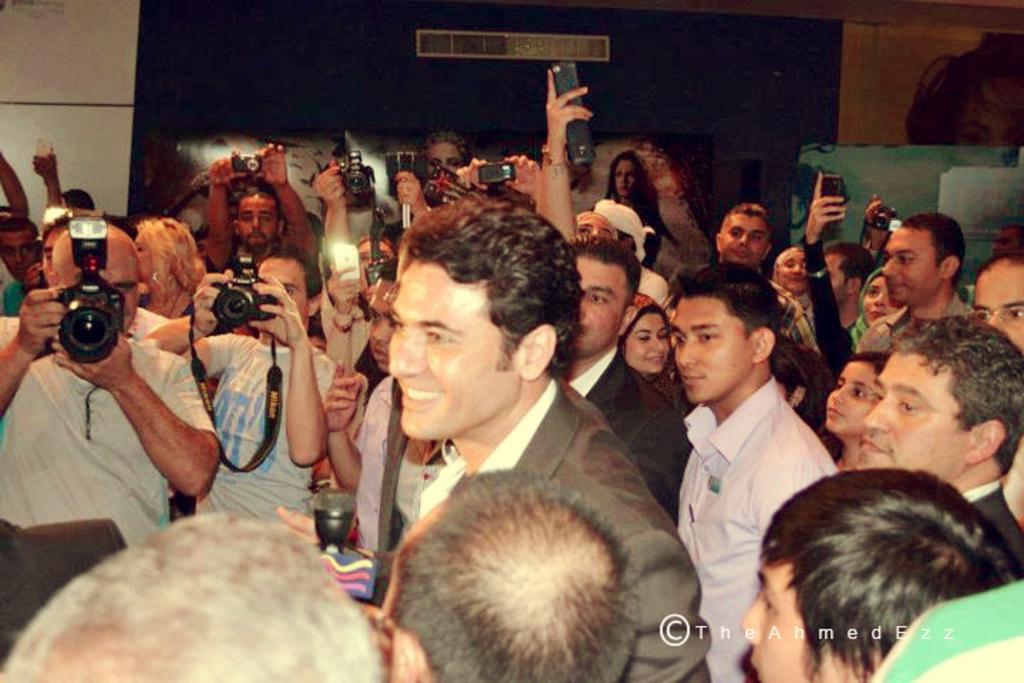In one or two sentences, can you explain what this image depicts? There are many people. Some people are holding cameras. In the back there's a wall. On the right corner there is a watermark 